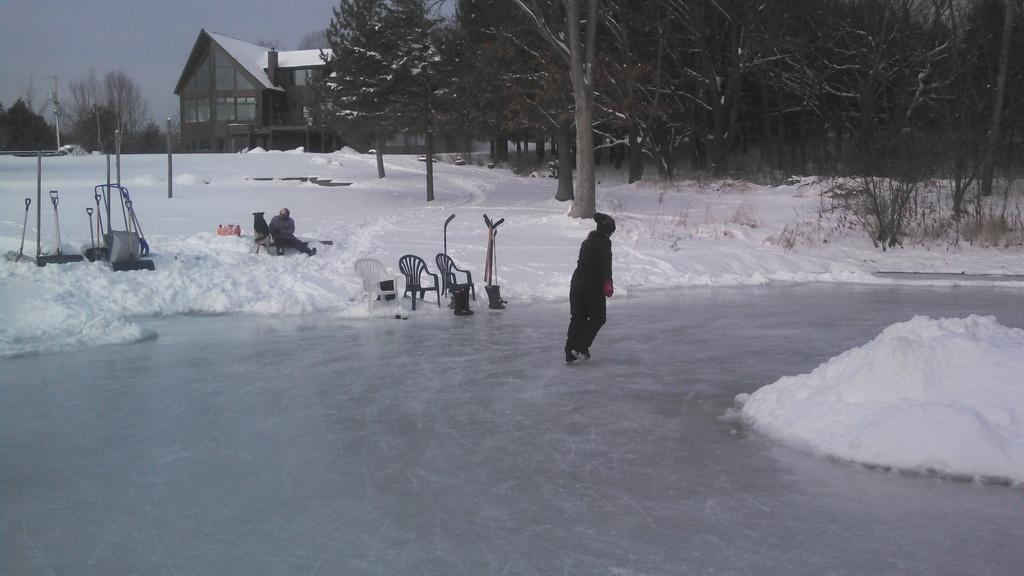What is the person in the image doing on the ice? The person is skating on the ice. What other objects can be seen in the image? There are chairs, sticks, trees, a house with a roof, and a pole visible in the image. Can you describe the trees in the image? The trees have visible bark in the image. What is visible in the background of the image? The sky is visible in the image. Are there any people sitting in the image? Yes, there is a person sitting on the ice. What type of police equipment can be seen in the image? There is no police equipment present in the image. What is the person sitting on the ice using to carry their basket? There is no basket present in the image. 